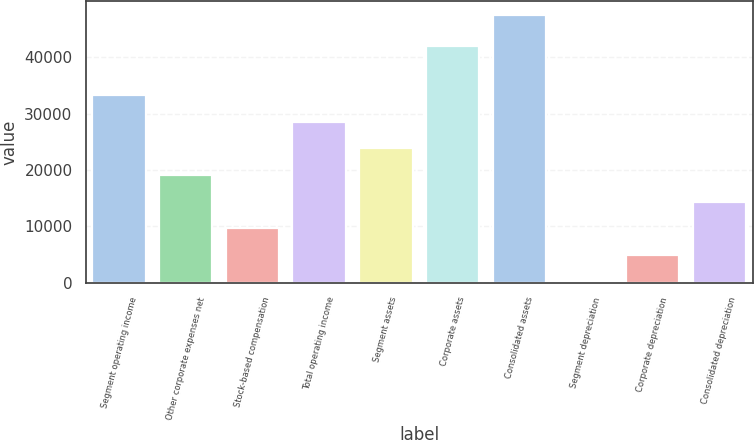Convert chart to OTSL. <chart><loc_0><loc_0><loc_500><loc_500><bar_chart><fcel>Segment operating income<fcel>Other corporate expenses net<fcel>Stock-based compensation<fcel>Total operating income<fcel>Segment assets<fcel>Corporate assets<fcel>Consolidated assets<fcel>Segment depreciation<fcel>Corporate depreciation<fcel>Consolidated depreciation<nl><fcel>33301.7<fcel>19102.4<fcel>9636.2<fcel>28568.6<fcel>23835.5<fcel>41897<fcel>47501<fcel>170<fcel>4903.1<fcel>14369.3<nl></chart> 